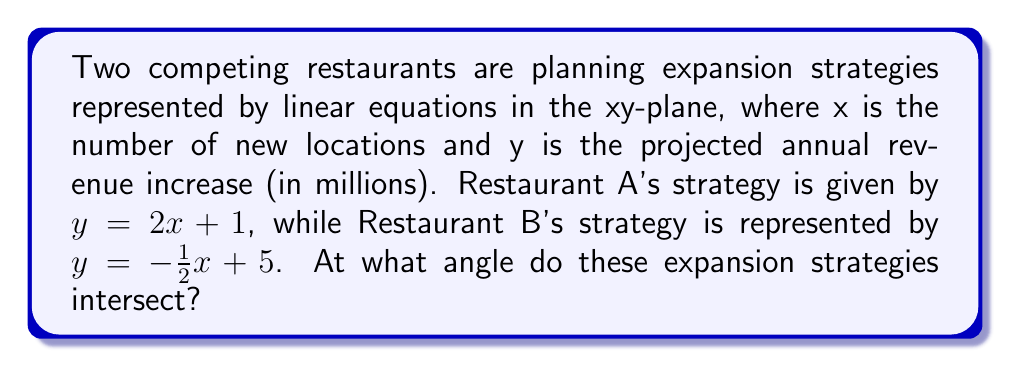Help me with this question. To find the angle of intersection between these two expansion strategies, we'll follow these steps:

1) First, recall that the angle between two lines can be found using the formula:
   
   $$\tan \theta = \left|\frac{m_1 - m_2}{1 + m_1m_2}\right|$$
   
   where $m_1$ and $m_2$ are the slopes of the two lines.

2) For Restaurant A's strategy: $y = 2x + 1$
   The slope $m_1 = 2$

3) For Restaurant B's strategy: $y = -\frac{1}{2}x + 5$
   The slope $m_2 = -\frac{1}{2}$

4) Now, let's substitute these values into our formula:

   $$\tan \theta = \left|\frac{2 - (-\frac{1}{2})}{1 + 2(-\frac{1}{2})}\right|$$

5) Simplify the numerator and denominator:

   $$\tan \theta = \left|\frac{2 + \frac{1}{2}}{1 - 1}\right| = \left|\frac{\frac{5}{2}}{0}\right|$$

6) The denominator is zero, which means the angle is 90°. This makes sense geometrically, as one line has a positive slope and the other a negative slope, indicating they are perpendicular.

7) Therefore, the angle of intersection is 90°.
Answer: 90° 